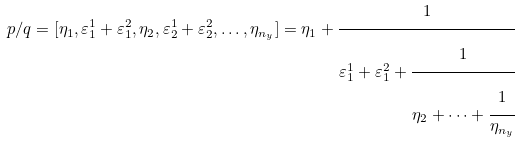<formula> <loc_0><loc_0><loc_500><loc_500>p / q = [ \eta _ { 1 } , \varepsilon _ { 1 } ^ { 1 } + \varepsilon _ { 1 } ^ { 2 } , \eta _ { 2 } , \varepsilon _ { 2 } ^ { 1 } + \varepsilon _ { 2 } ^ { 2 } , \dots , \eta _ { n _ { y } } ] = \eta _ { 1 } + \cfrac { 1 } { \varepsilon _ { 1 } ^ { 1 } + \varepsilon _ { 1 } ^ { 2 } + \cfrac { 1 } { \eta _ { 2 } + \dots + \cfrac { 1 } { \eta _ { n _ { y } } } } }</formula> 